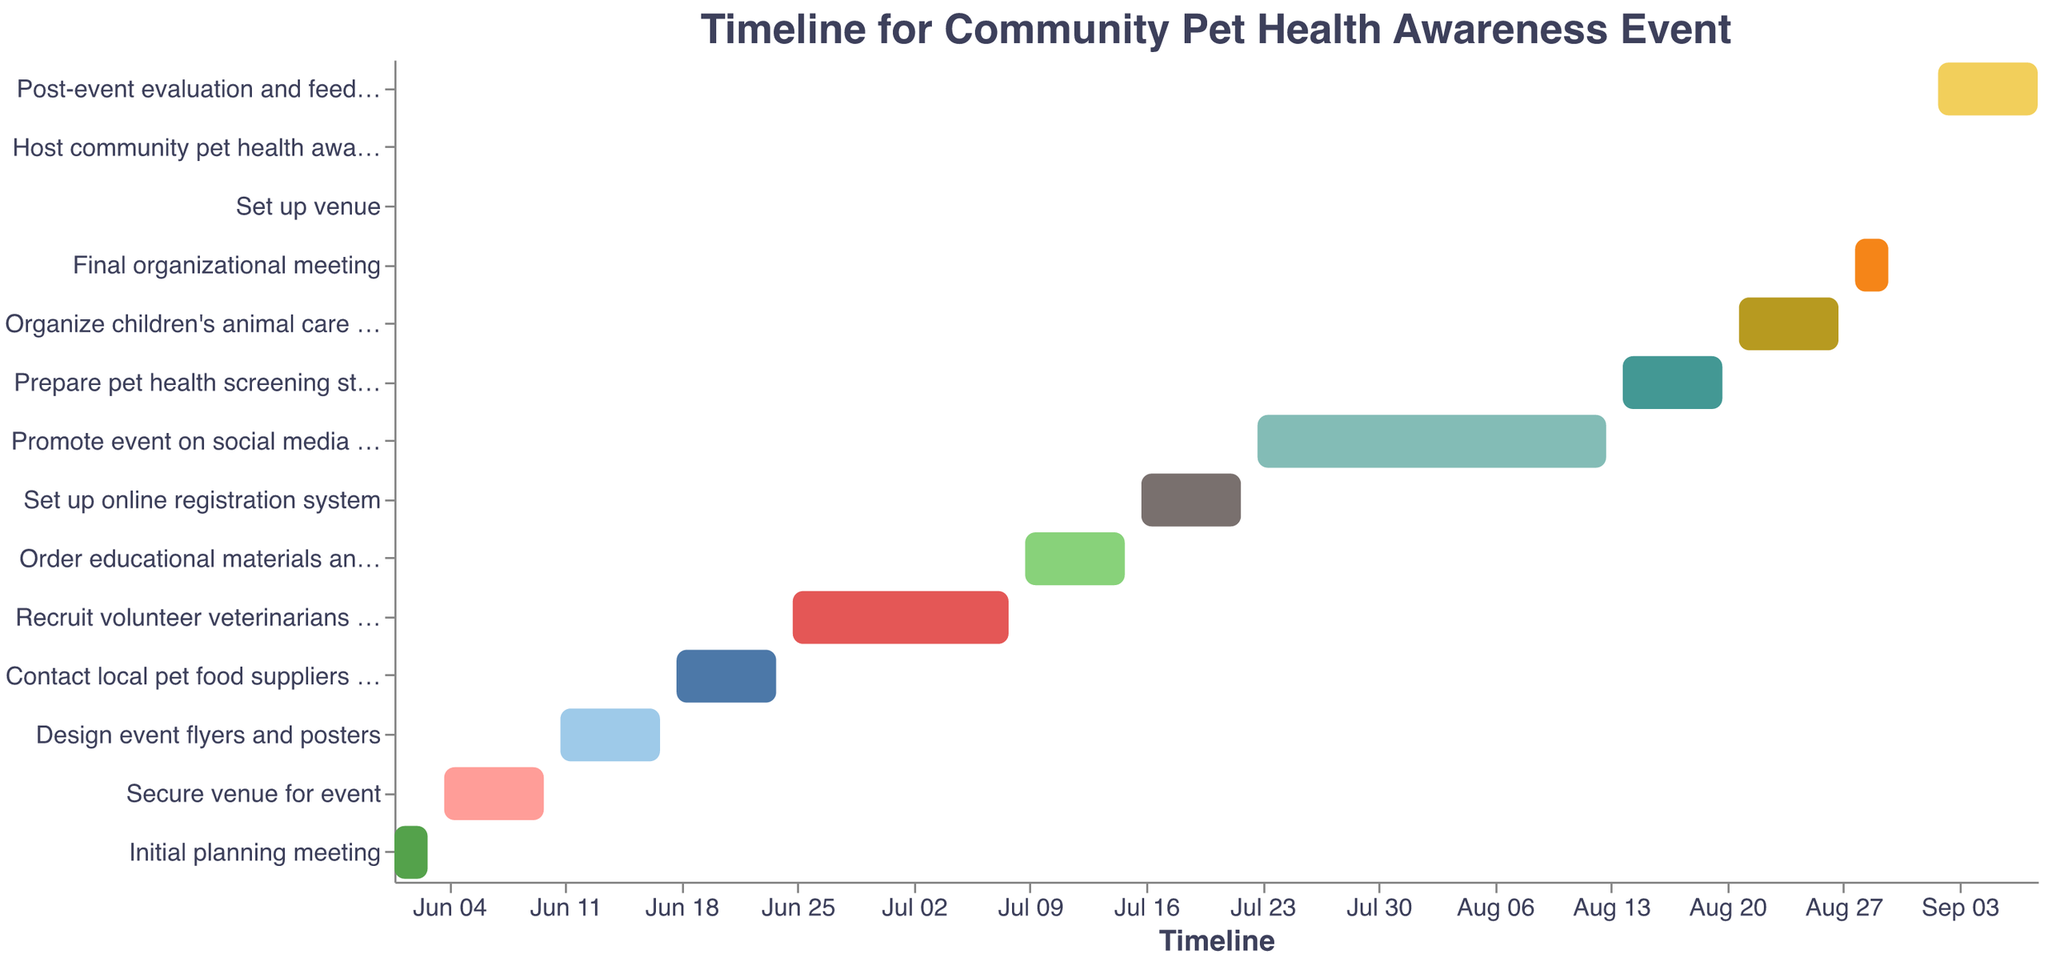What's the title of the figure? The title is usually at the top of the figure. By looking at the top center of the plot, we can see the text displaying the title.
Answer: Timeline for Community Pet Health Awareness Event What is the first task in the timeline? The tasks start from the top and go downwards. The first task listed from the top is "Initial planning meeting".
Answer: Initial planning meeting Which task takes the longest duration to complete? We can determine the longest duration by comparing the length of the bars representing each task. "Promote event on social media and local news" has the longest bar, indicating it takes the longest time.
Answer: Promote event on social media and local news When does the task "Organize children’s animal care workshop" start and end? By finding the "Organize children’s animal care workshop" in the list of tasks on the y-axis, we look at the start and end points on the x-axis to see the dates. This task starts on August 21, 2023, and ends on August 27, 2023.
Answer: August 21, 2023, and August 27, 2023 How many tasks are scheduled to start in July? By counting the tasks that have their start dates in July, we can find out how many there are. There are three tasks that start in July.
Answer: 3 Which tasks are scheduled to start after the "Order educational materials and handouts" finishes? The "Order educational materials and handouts" ends on July 15, 2023. The tasks that start after this date are "Set up online registration system", "Promote event on social media and local news", "Prepare pet health screening stations", "Organize children's animal care workshop", "Final organizational meeting", "Set up venue", "Host community pet health awareness event", and "Post-event evaluation and feedback collection".
Answer: Set up online registration system, Promote event on social media and local news, Prepare pet health screening stations, Organize children's animal care workshop, Final organizational meeting, Set up venue, Host community pet health awareness event, Post-event evaluation and feedback collection What is the duration of "Recruit volunteer veterinarians and vet techs"? By looking at the start and end dates for "Recruit volunteer veterinarians and vet techs", we see that it starts on June 25, 2023, and ends on July 8, 2023, giving it a duration of 14 days.
Answer: 14 days Which tasks overlap with the "Promote event on social media and local news"? By examining the timeline, we can see which tasks have date ranges that overlap with the "Promote event on social media and local news", which runs from July 23, 2023, to August 13, 2023. The overlapping tasks are "Set up online registration system", "Prepare pet health screening stations", "Organize children’s animal care workshop", "Final organizational meeting".
Answer: Set up online registration system, Prepare pet health screening stations, Organize children's animal care workshop, Final organizational meeting How many tasks are scheduled to be completed in one day? By identifying the tasks that have the same start and end date, we see that "Set up venue" and "Host community pet health awareness event" are both completed in one day.
Answer: 2 